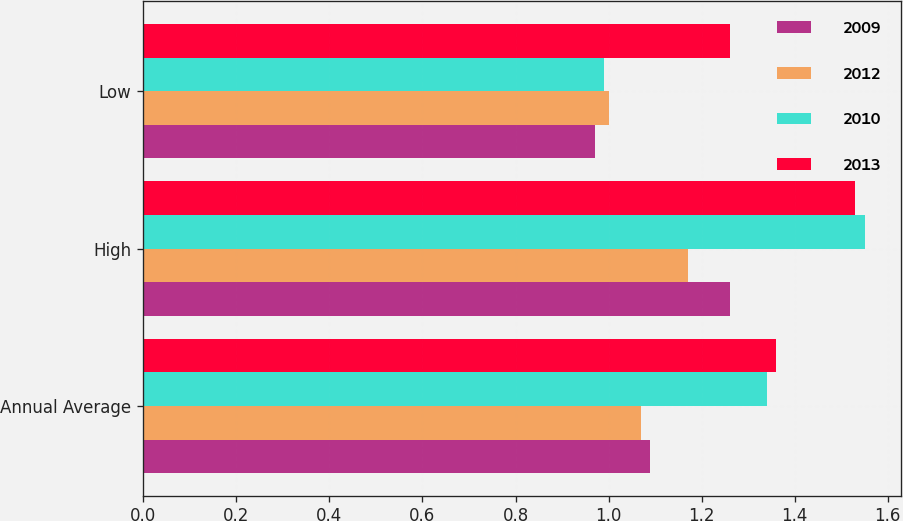<chart> <loc_0><loc_0><loc_500><loc_500><stacked_bar_chart><ecel><fcel>Annual Average<fcel>High<fcel>Low<nl><fcel>2009<fcel>1.09<fcel>1.26<fcel>0.97<nl><fcel>2012<fcel>1.07<fcel>1.17<fcel>1<nl><fcel>2010<fcel>1.34<fcel>1.55<fcel>0.99<nl><fcel>2013<fcel>1.36<fcel>1.53<fcel>1.26<nl></chart> 